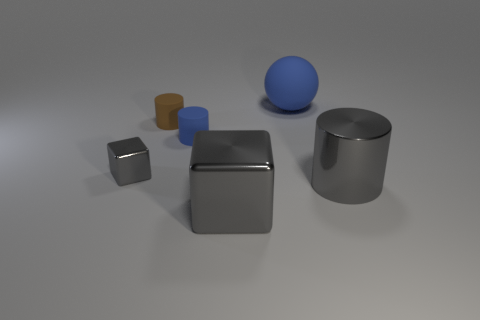The large object behind the small object that is on the right side of the cylinder that is on the left side of the small blue rubber cylinder is what shape?
Make the answer very short. Sphere. Are there fewer tiny cylinders that are behind the small brown matte thing than gray cylinders on the left side of the blue rubber sphere?
Provide a succinct answer. No. Is there a large rubber cube of the same color as the large metallic cube?
Offer a terse response. No. Is the material of the tiny brown cylinder the same as the blue thing to the right of the big cube?
Your answer should be very brief. Yes. There is a blue cylinder on the left side of the rubber ball; are there any brown rubber things in front of it?
Offer a terse response. No. The small thing that is in front of the tiny brown matte cylinder and to the right of the tiny gray shiny block is what color?
Provide a succinct answer. Blue. The blue cylinder is what size?
Provide a succinct answer. Small. How many purple things have the same size as the gray cylinder?
Your answer should be very brief. 0. Are the big thing that is behind the blue rubber cylinder and the tiny cylinder on the left side of the small blue matte cylinder made of the same material?
Make the answer very short. Yes. The gray cube that is in front of the gray metallic thing left of the tiny brown thing is made of what material?
Ensure brevity in your answer.  Metal. 